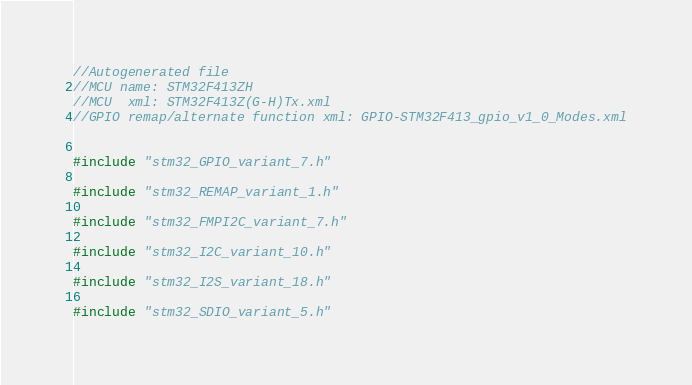<code> <loc_0><loc_0><loc_500><loc_500><_C_>//Autogenerated file
//MCU name: STM32F413ZH
//MCU  xml: STM32F413Z(G-H)Tx.xml
//GPIO remap/alternate function xml: GPIO-STM32F413_gpio_v1_0_Modes.xml


#include "stm32_GPIO_variant_7.h"

#include "stm32_REMAP_variant_1.h"

#include "stm32_FMPI2C_variant_7.h"

#include "stm32_I2C_variant_10.h"

#include "stm32_I2S_variant_18.h"

#include "stm32_SDIO_variant_5.h"
</code> 